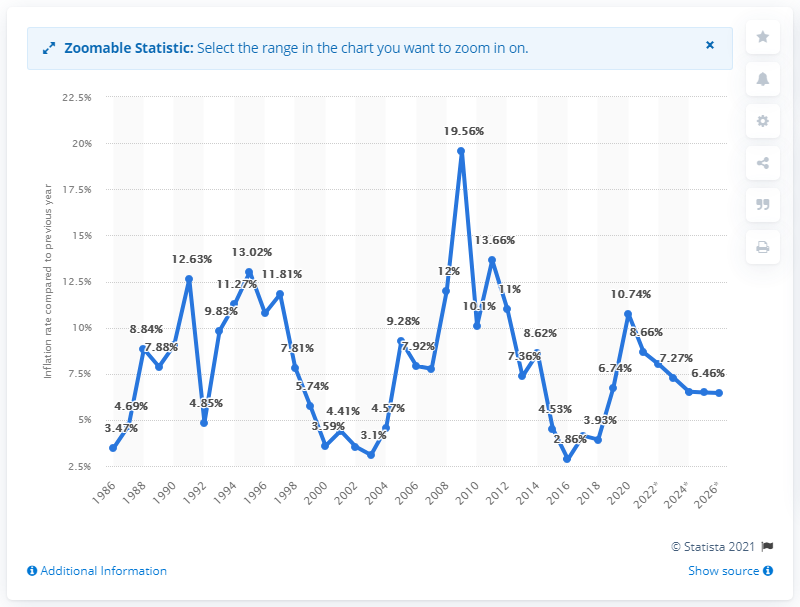Highlight a few significant elements in this photo. Pakistan's inflation rate is expected to stabilize at a moderate level of 6.46% over the next few years, according to current forecasts. 